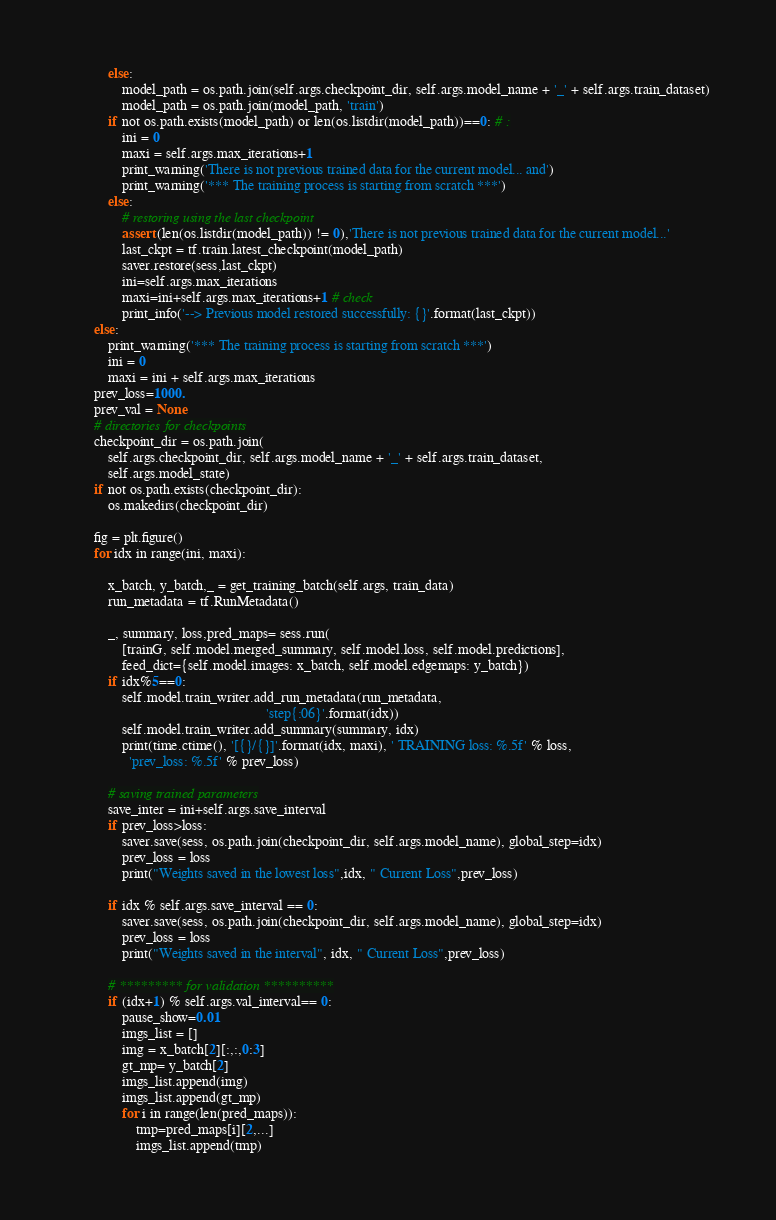<code> <loc_0><loc_0><loc_500><loc_500><_Python_>            else:
                model_path = os.path.join(self.args.checkpoint_dir, self.args.model_name + '_' + self.args.train_dataset)
                model_path = os.path.join(model_path, 'train')
            if not os.path.exists(model_path) or len(os.listdir(model_path))==0: # :
                ini = 0
                maxi = self.args.max_iterations+1
                print_warning('There is not previous trained data for the current model... and')
                print_warning('*** The training process is starting from scratch ***')
            else:
                # restoring using the last checkpoint
                assert (len(os.listdir(model_path)) != 0),'There is not previous trained data for the current model...'
                last_ckpt = tf.train.latest_checkpoint(model_path)
                saver.restore(sess,last_ckpt)
                ini=self.args.max_iterations
                maxi=ini+self.args.max_iterations+1 # check
                print_info('--> Previous model restored successfully: {}'.format(last_ckpt))
        else:
            print_warning('*** The training process is starting from scratch ***')
            ini = 0
            maxi = ini + self.args.max_iterations
        prev_loss=1000.
        prev_val = None
        # directories for checkpoints
        checkpoint_dir = os.path.join(
            self.args.checkpoint_dir, self.args.model_name + '_' + self.args.train_dataset,
            self.args.model_state)
        if not os.path.exists(checkpoint_dir):
            os.makedirs(checkpoint_dir)

        fig = plt.figure()
        for idx in range(ini, maxi):

            x_batch, y_batch,_ = get_training_batch(self.args, train_data)
            run_metadata = tf.RunMetadata()

            _, summary, loss,pred_maps= sess.run(
                [trainG, self.model.merged_summary, self.model.loss, self.model.predictions],
                feed_dict={self.model.images: x_batch, self.model.edgemaps: y_batch})
            if idx%5==0:
                self.model.train_writer.add_run_metadata(run_metadata,
                                                         'step{:06}'.format(idx))
                self.model.train_writer.add_summary(summary, idx)
                print(time.ctime(), '[{}/{}]'.format(idx, maxi), ' TRAINING loss: %.5f' % loss,
                  'prev_loss: %.5f' % prev_loss)

            # saving trained parameters
            save_inter = ini+self.args.save_interval
            if prev_loss>loss:
                saver.save(sess, os.path.join(checkpoint_dir, self.args.model_name), global_step=idx)
                prev_loss = loss
                print("Weights saved in the lowest loss",idx, " Current Loss",prev_loss)

            if idx % self.args.save_interval == 0:
                saver.save(sess, os.path.join(checkpoint_dir, self.args.model_name), global_step=idx)
                prev_loss = loss
                print("Weights saved in the interval", idx, " Current Loss",prev_loss)

            # ********* for validation **********
            if (idx+1) % self.args.val_interval== 0:
                pause_show=0.01
                imgs_list = []
                img = x_batch[2][:,:,0:3]
                gt_mp= y_batch[2]
                imgs_list.append(img)
                imgs_list.append(gt_mp)
                for i in range(len(pred_maps)):
                    tmp=pred_maps[i][2,...]
                    imgs_list.append(tmp)</code> 